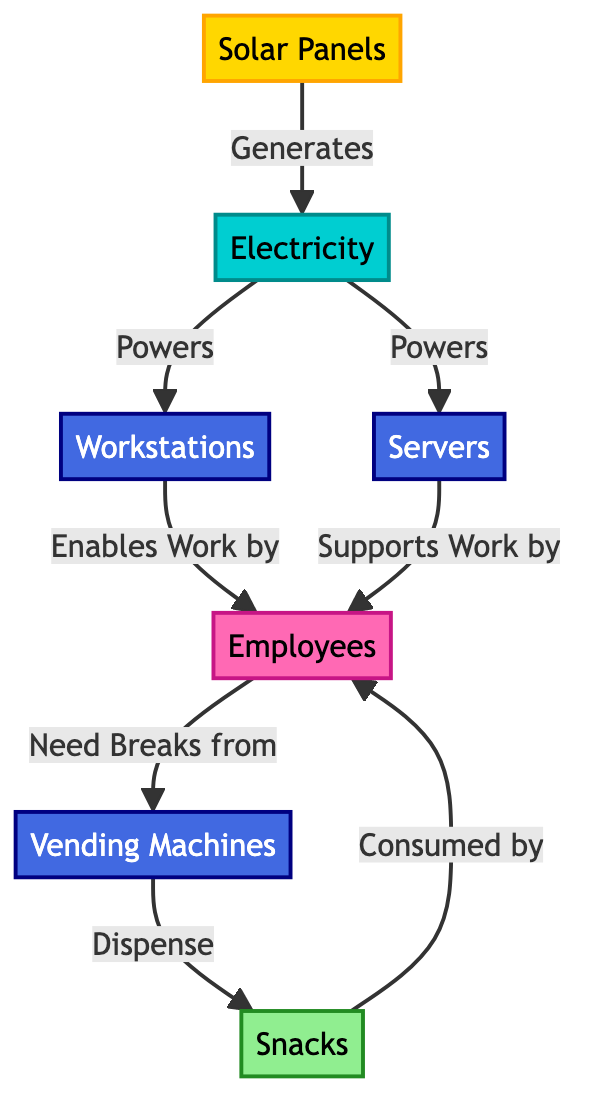What generates electricity in the office ecosystem? The diagram indicates "Solar Panels" as the entity that generates electricity, which is the starting point of the energy flow.
Answer: Solar Panels How many tech nodes are present in the diagram? There are three tech nodes: "Workstations," "Servers," and "Vending Machines." Counting them, we arrive at a total of three nodes in this category.
Answer: 3 What do employees consume? According to the diagram, employees consume "Snacks," which are dispensed by the vending machines after the employees need breaks.
Answer: Snacks What supports work by employees? The diagram shows "Servers" as the component that supports work done by the employees, along with workstations which are also mentioned but are specifically framed in a different function.
Answer: Servers Which node receives energy directly from electricity? The nodes that receive energy directly from electricity are "Workstations" and "Servers," as indicated by the arrows leading from electricity to these nodes.
Answer: Workstations, Servers How does energy flow from "Solar Panels" to "Snacks"? The flow begins with "Solar Panels" generating electricity, which powers "Workstations" and "Servers." Employees use these tech nodes to work and then use "Vending Machines" to get snacks. The connection is established through several steps.
Answer: Solar Panels → Electricity → Workstations/Servers → Employees → Vending Machines → Snacks What role do vending machines play in the ecosystem? The diagram shows that vending machines dispense snacks, acting as a bridge between the employees' need for breaks and the food they consume during those breaks.
Answer: Dispense snacks Who enables work in this office ecosystem? The diagram states that "Employees" are enabled to work by "Workstations" and supported by "Servers," which shows the role of human resources facilitated by tech nodes.
Answer: Employees What is the relationship between employees and vending machines? Employees have a direct need for breaks that leads them to interact with vending machines for snacks, showing their dependency on vending machines for that aspect of well-being.
Answer: Need breaks from 